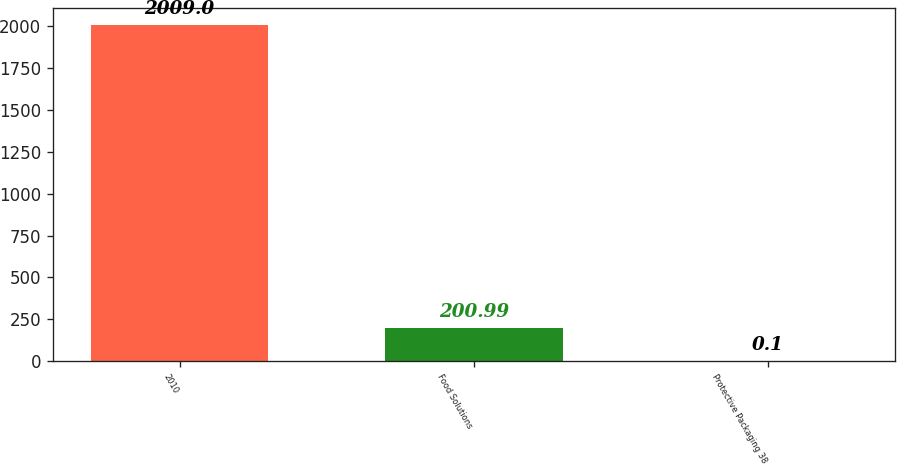Convert chart. <chart><loc_0><loc_0><loc_500><loc_500><bar_chart><fcel>2010<fcel>Food Solutions<fcel>Protective Packaging 38<nl><fcel>2009<fcel>200.99<fcel>0.1<nl></chart> 